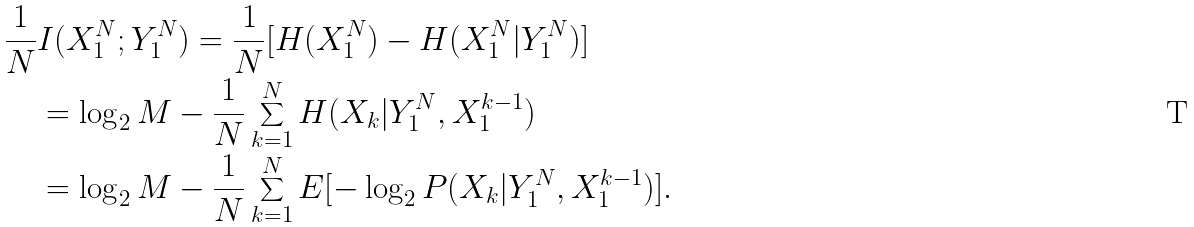Convert formula to latex. <formula><loc_0><loc_0><loc_500><loc_500>\frac { 1 } { N } & I ( X ^ { N } _ { 1 } ; Y ^ { N } _ { 1 } ) = \frac { 1 } { N } [ H ( X ^ { N } _ { 1 } ) - H ( X ^ { N } _ { 1 } | Y ^ { N } _ { 1 } ) ] \\ & = \log _ { 2 } M - \frac { 1 } { N } \sum _ { k = 1 } ^ { N } H ( X _ { k } | Y ^ { N } _ { 1 } , X _ { 1 } ^ { k - 1 } ) \\ & = \log _ { 2 } M - \frac { 1 } { N } \sum _ { k = 1 } ^ { N } E [ - \log _ { 2 } P ( X _ { k } | Y _ { 1 } ^ { N } , X _ { 1 } ^ { k - 1 } ) ] .</formula> 